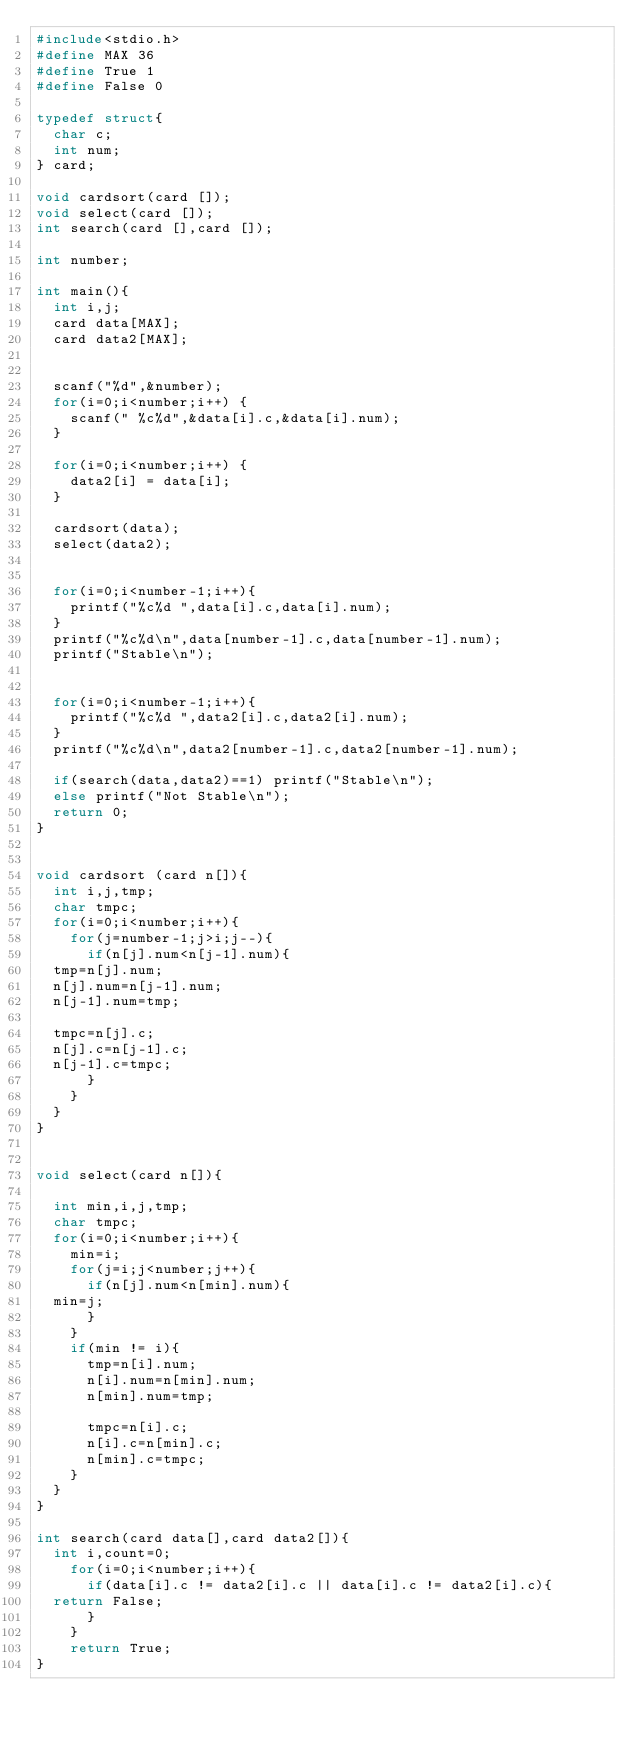Convert code to text. <code><loc_0><loc_0><loc_500><loc_500><_C_>#include<stdio.h>
#define MAX 36
#define True 1
#define False 0

typedef struct{
  char c;
  int num;
} card;

void cardsort(card []);
void select(card []);
int search(card [],card []); 

int number;

int main(){
  int i,j;
  card data[MAX];
  card data2[MAX];
  
  
  scanf("%d",&number);
  for(i=0;i<number;i++) {
    scanf(" %c%d",&data[i].c,&data[i].num);
  }
  
  for(i=0;i<number;i++) {
    data2[i] = data[i];
  }
  
  cardsort(data);
  select(data2);

  
  for(i=0;i<number-1;i++){
    printf("%c%d ",data[i].c,data[i].num);
  }
  printf("%c%d\n",data[number-1].c,data[number-1].num);
  printf("Stable\n");

  
  for(i=0;i<number-1;i++){
    printf("%c%d ",data2[i].c,data2[i].num);
  }
  printf("%c%d\n",data2[number-1].c,data2[number-1].num);

  if(search(data,data2)==1) printf("Stable\n");
  else printf("Not Stable\n");
  return 0;
}


void cardsort (card n[]){
  int i,j,tmp;
  char tmpc;
  for(i=0;i<number;i++){
    for(j=number-1;j>i;j--){
      if(n[j].num<n[j-1].num){
	tmp=n[j].num;
	n[j].num=n[j-1].num;
	n[j-1].num=tmp;

	tmpc=n[j].c;
	n[j].c=n[j-1].c;
	n[j-1].c=tmpc;
      }
    }
  }
}


void select(card n[]){

  int min,i,j,tmp;
  char tmpc;
  for(i=0;i<number;i++){
    min=i;
    for(j=i;j<number;j++){
      if(n[j].num<n[min].num){
	min=j;
      }
    }
    if(min != i){
      tmp=n[i].num;
      n[i].num=n[min].num;
      n[min].num=tmp;

      tmpc=n[i].c;
      n[i].c=n[min].c;
      n[min].c=tmpc;
    }
  }
}

int search(card data[],card data2[]){
  int i,count=0;
    for(i=0;i<number;i++){
      if(data[i].c != data2[i].c || data[i].c != data2[i].c){
	return False;
      }
    }
    return True;
}</code> 